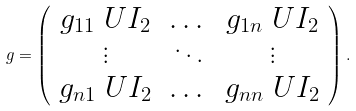Convert formula to latex. <formula><loc_0><loc_0><loc_500><loc_500>g = \left ( \begin{array} { c c c } g _ { 1 1 } \ U I _ { 2 } & \dots & g _ { 1 n } \ U I _ { 2 } \\ \vdots & \ddots & \vdots \\ g _ { n 1 } \ U I _ { 2 } & \dots & g _ { n n } \ U I _ { 2 } \\ \end{array} \right ) .</formula> 